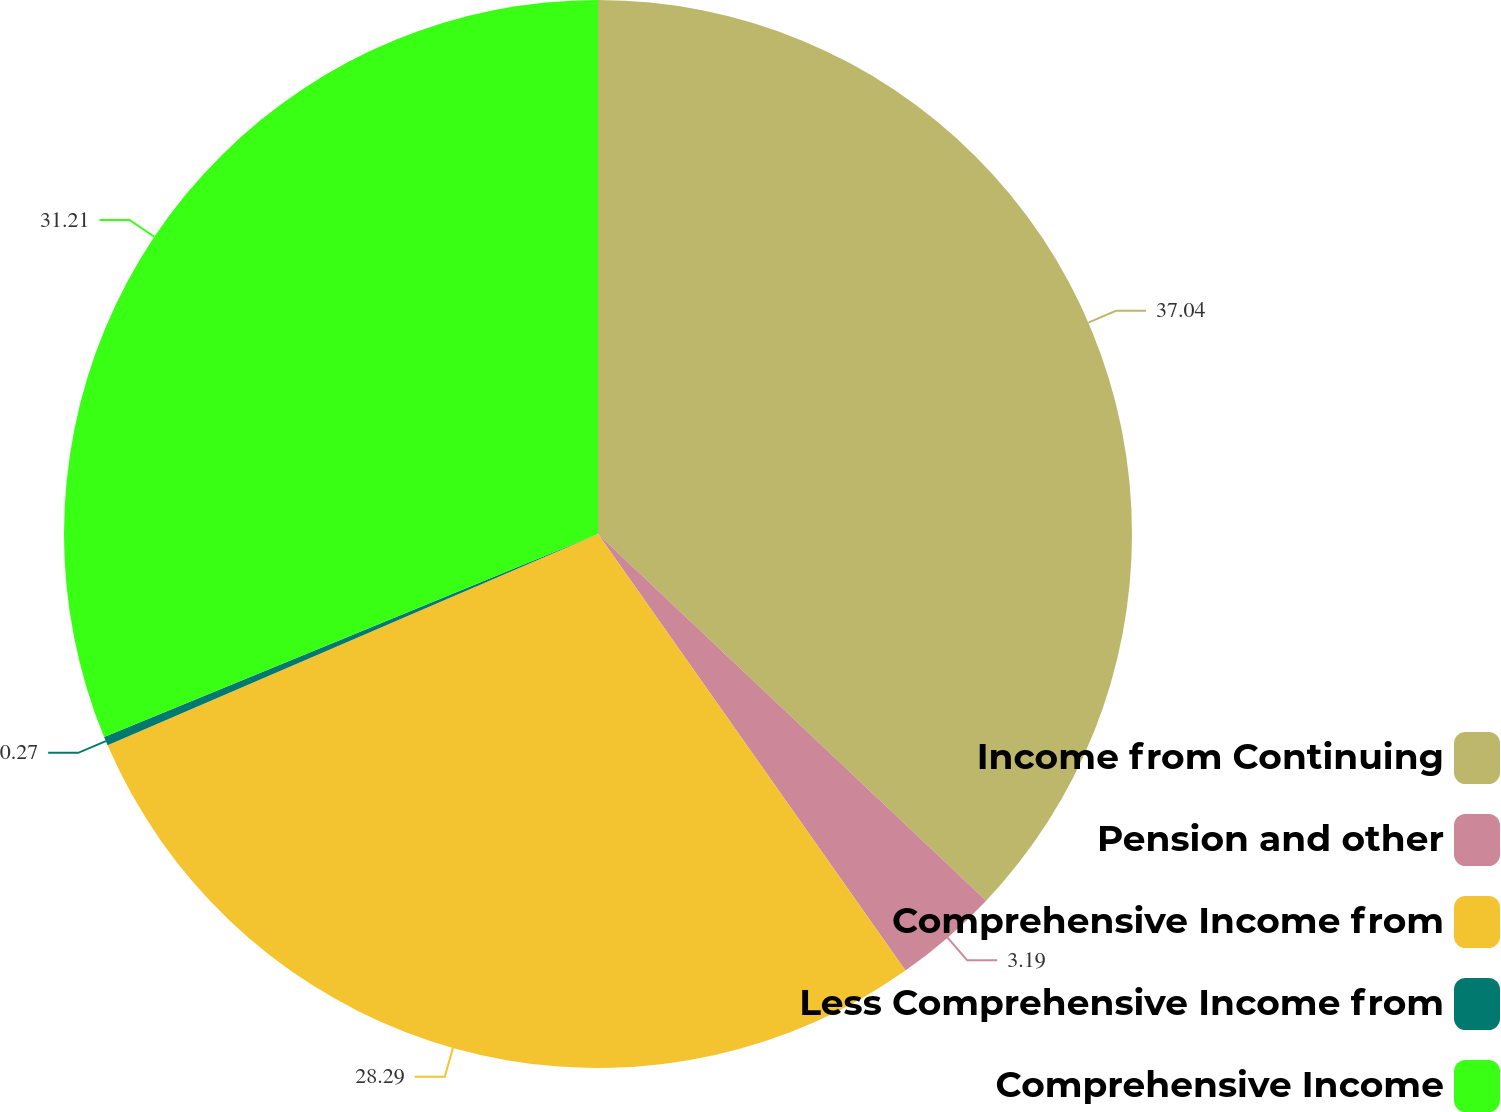<chart> <loc_0><loc_0><loc_500><loc_500><pie_chart><fcel>Income from Continuing<fcel>Pension and other<fcel>Comprehensive Income from<fcel>Less Comprehensive Income from<fcel>Comprehensive Income<nl><fcel>37.05%<fcel>3.19%<fcel>28.29%<fcel>0.27%<fcel>31.21%<nl></chart> 